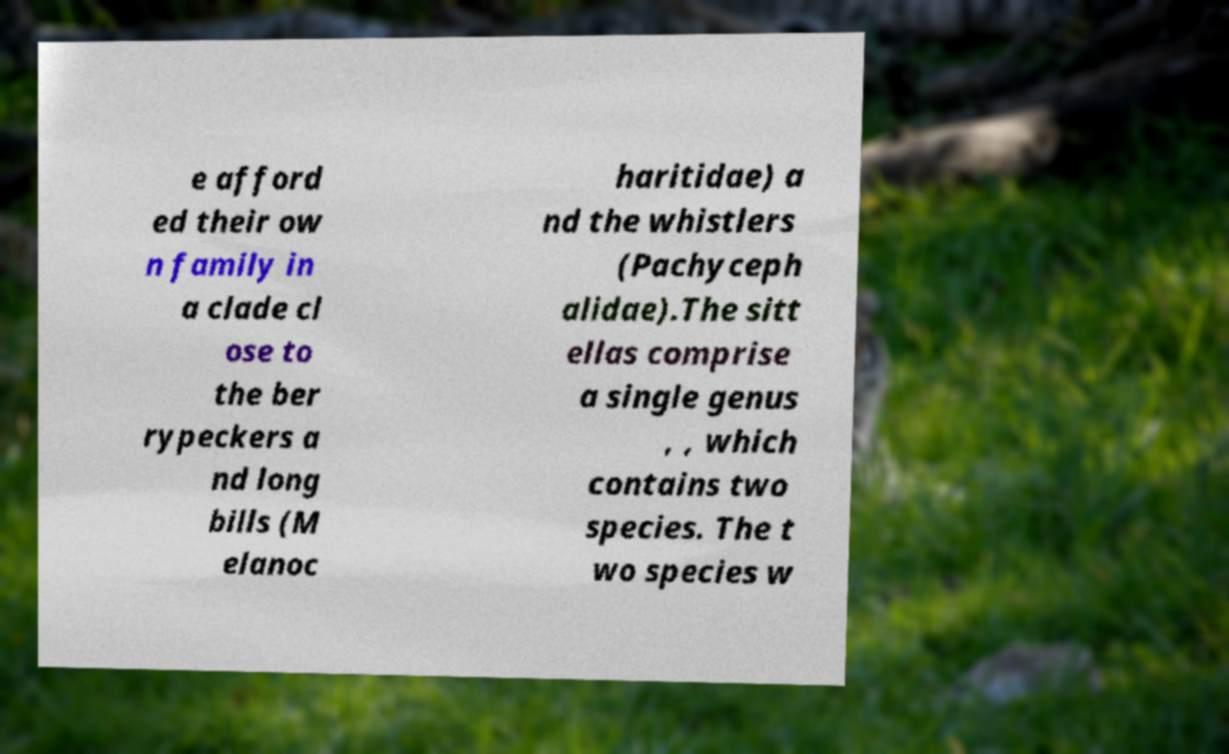There's text embedded in this image that I need extracted. Can you transcribe it verbatim? e afford ed their ow n family in a clade cl ose to the ber rypeckers a nd long bills (M elanoc haritidae) a nd the whistlers (Pachyceph alidae).The sitt ellas comprise a single genus , , which contains two species. The t wo species w 